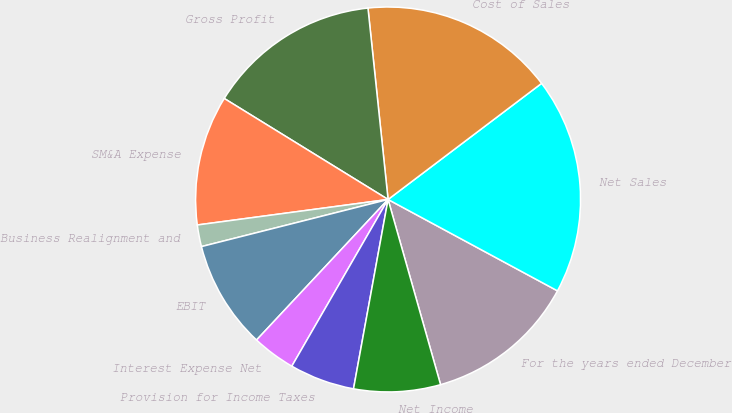<chart> <loc_0><loc_0><loc_500><loc_500><pie_chart><fcel>For the years ended December<fcel>Net Sales<fcel>Cost of Sales<fcel>Gross Profit<fcel>SM&A Expense<fcel>Business Realignment and<fcel>EBIT<fcel>Interest Expense Net<fcel>Provision for Income Taxes<fcel>Net Income<nl><fcel>12.73%<fcel>18.18%<fcel>16.36%<fcel>14.54%<fcel>10.91%<fcel>1.82%<fcel>9.09%<fcel>3.64%<fcel>5.46%<fcel>7.27%<nl></chart> 